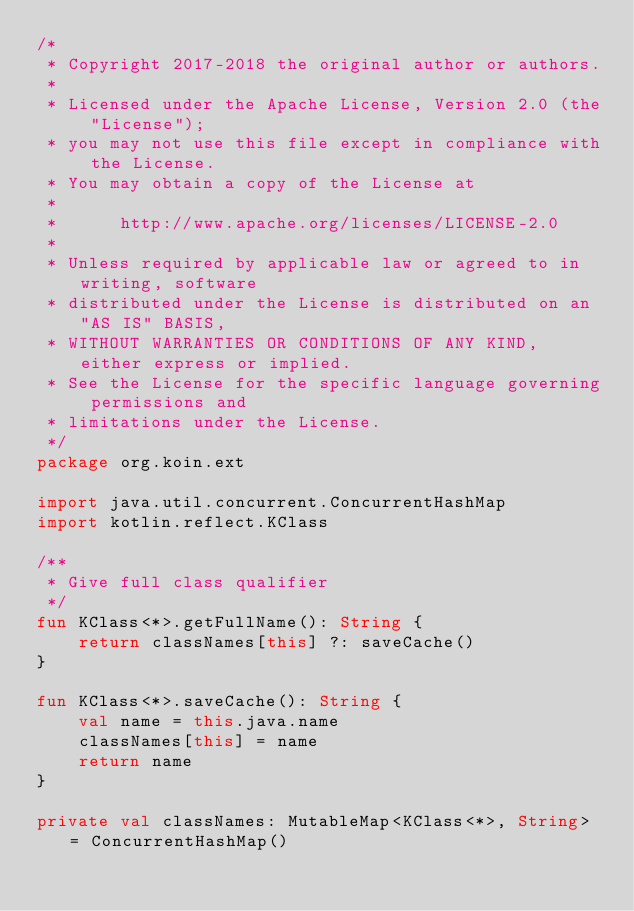<code> <loc_0><loc_0><loc_500><loc_500><_Kotlin_>/*
 * Copyright 2017-2018 the original author or authors.
 *
 * Licensed under the Apache License, Version 2.0 (the "License");
 * you may not use this file except in compliance with the License.
 * You may obtain a copy of the License at
 *
 *      http://www.apache.org/licenses/LICENSE-2.0
 *
 * Unless required by applicable law or agreed to in writing, software
 * distributed under the License is distributed on an "AS IS" BASIS,
 * WITHOUT WARRANTIES OR CONDITIONS OF ANY KIND, either express or implied.
 * See the License for the specific language governing permissions and
 * limitations under the License.
 */
package org.koin.ext

import java.util.concurrent.ConcurrentHashMap
import kotlin.reflect.KClass

/**
 * Give full class qualifier
 */
fun KClass<*>.getFullName(): String {
    return classNames[this] ?: saveCache()
}

fun KClass<*>.saveCache(): String {
    val name = this.java.name
    classNames[this] = name
    return name
}

private val classNames: MutableMap<KClass<*>, String> = ConcurrentHashMap()
</code> 